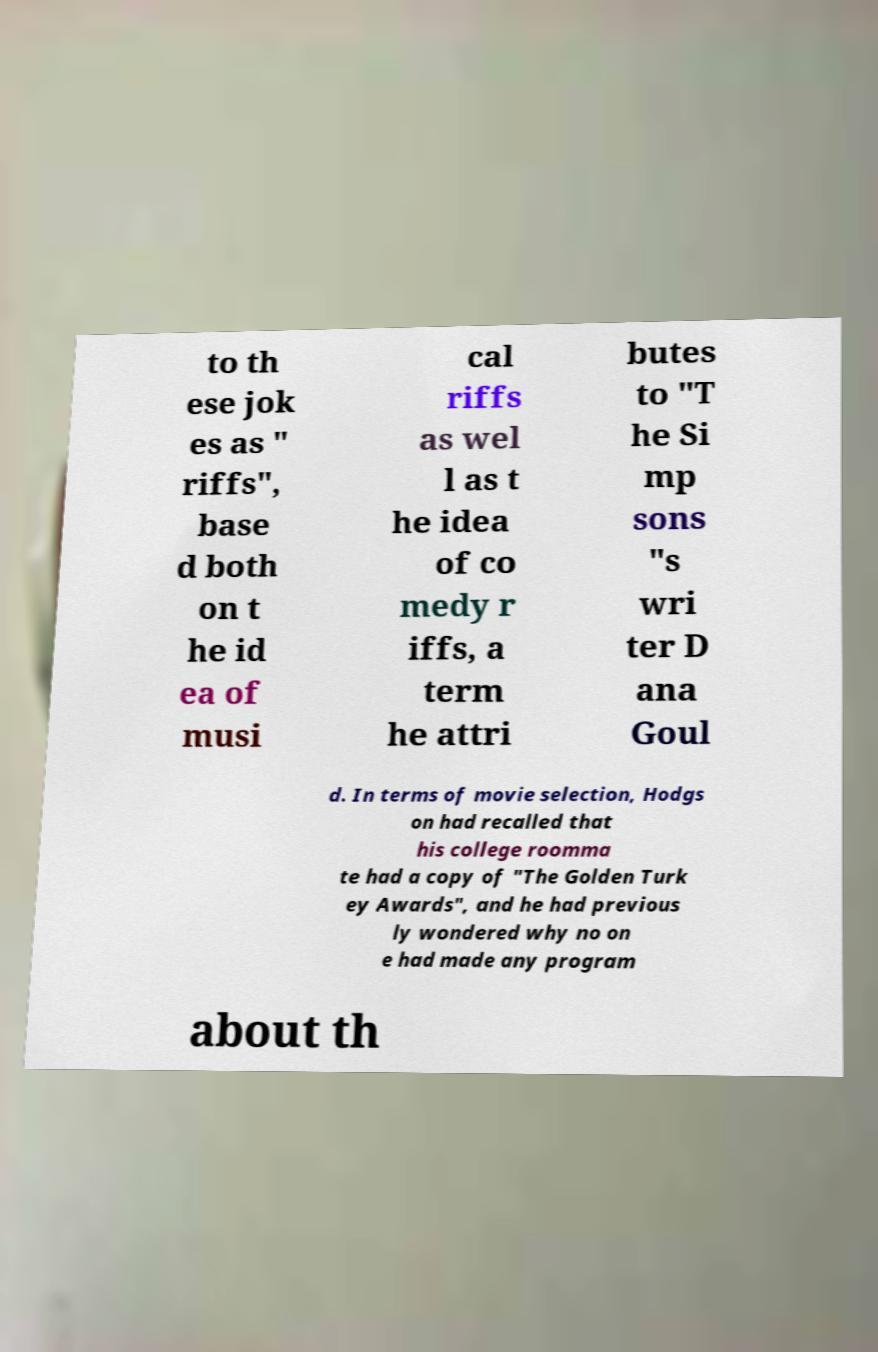Please read and relay the text visible in this image. What does it say? to th ese jok es as " riffs", base d both on t he id ea of musi cal riffs as wel l as t he idea of co medy r iffs, a term he attri butes to "T he Si mp sons "s wri ter D ana Goul d. In terms of movie selection, Hodgs on had recalled that his college roomma te had a copy of "The Golden Turk ey Awards", and he had previous ly wondered why no on e had made any program about th 